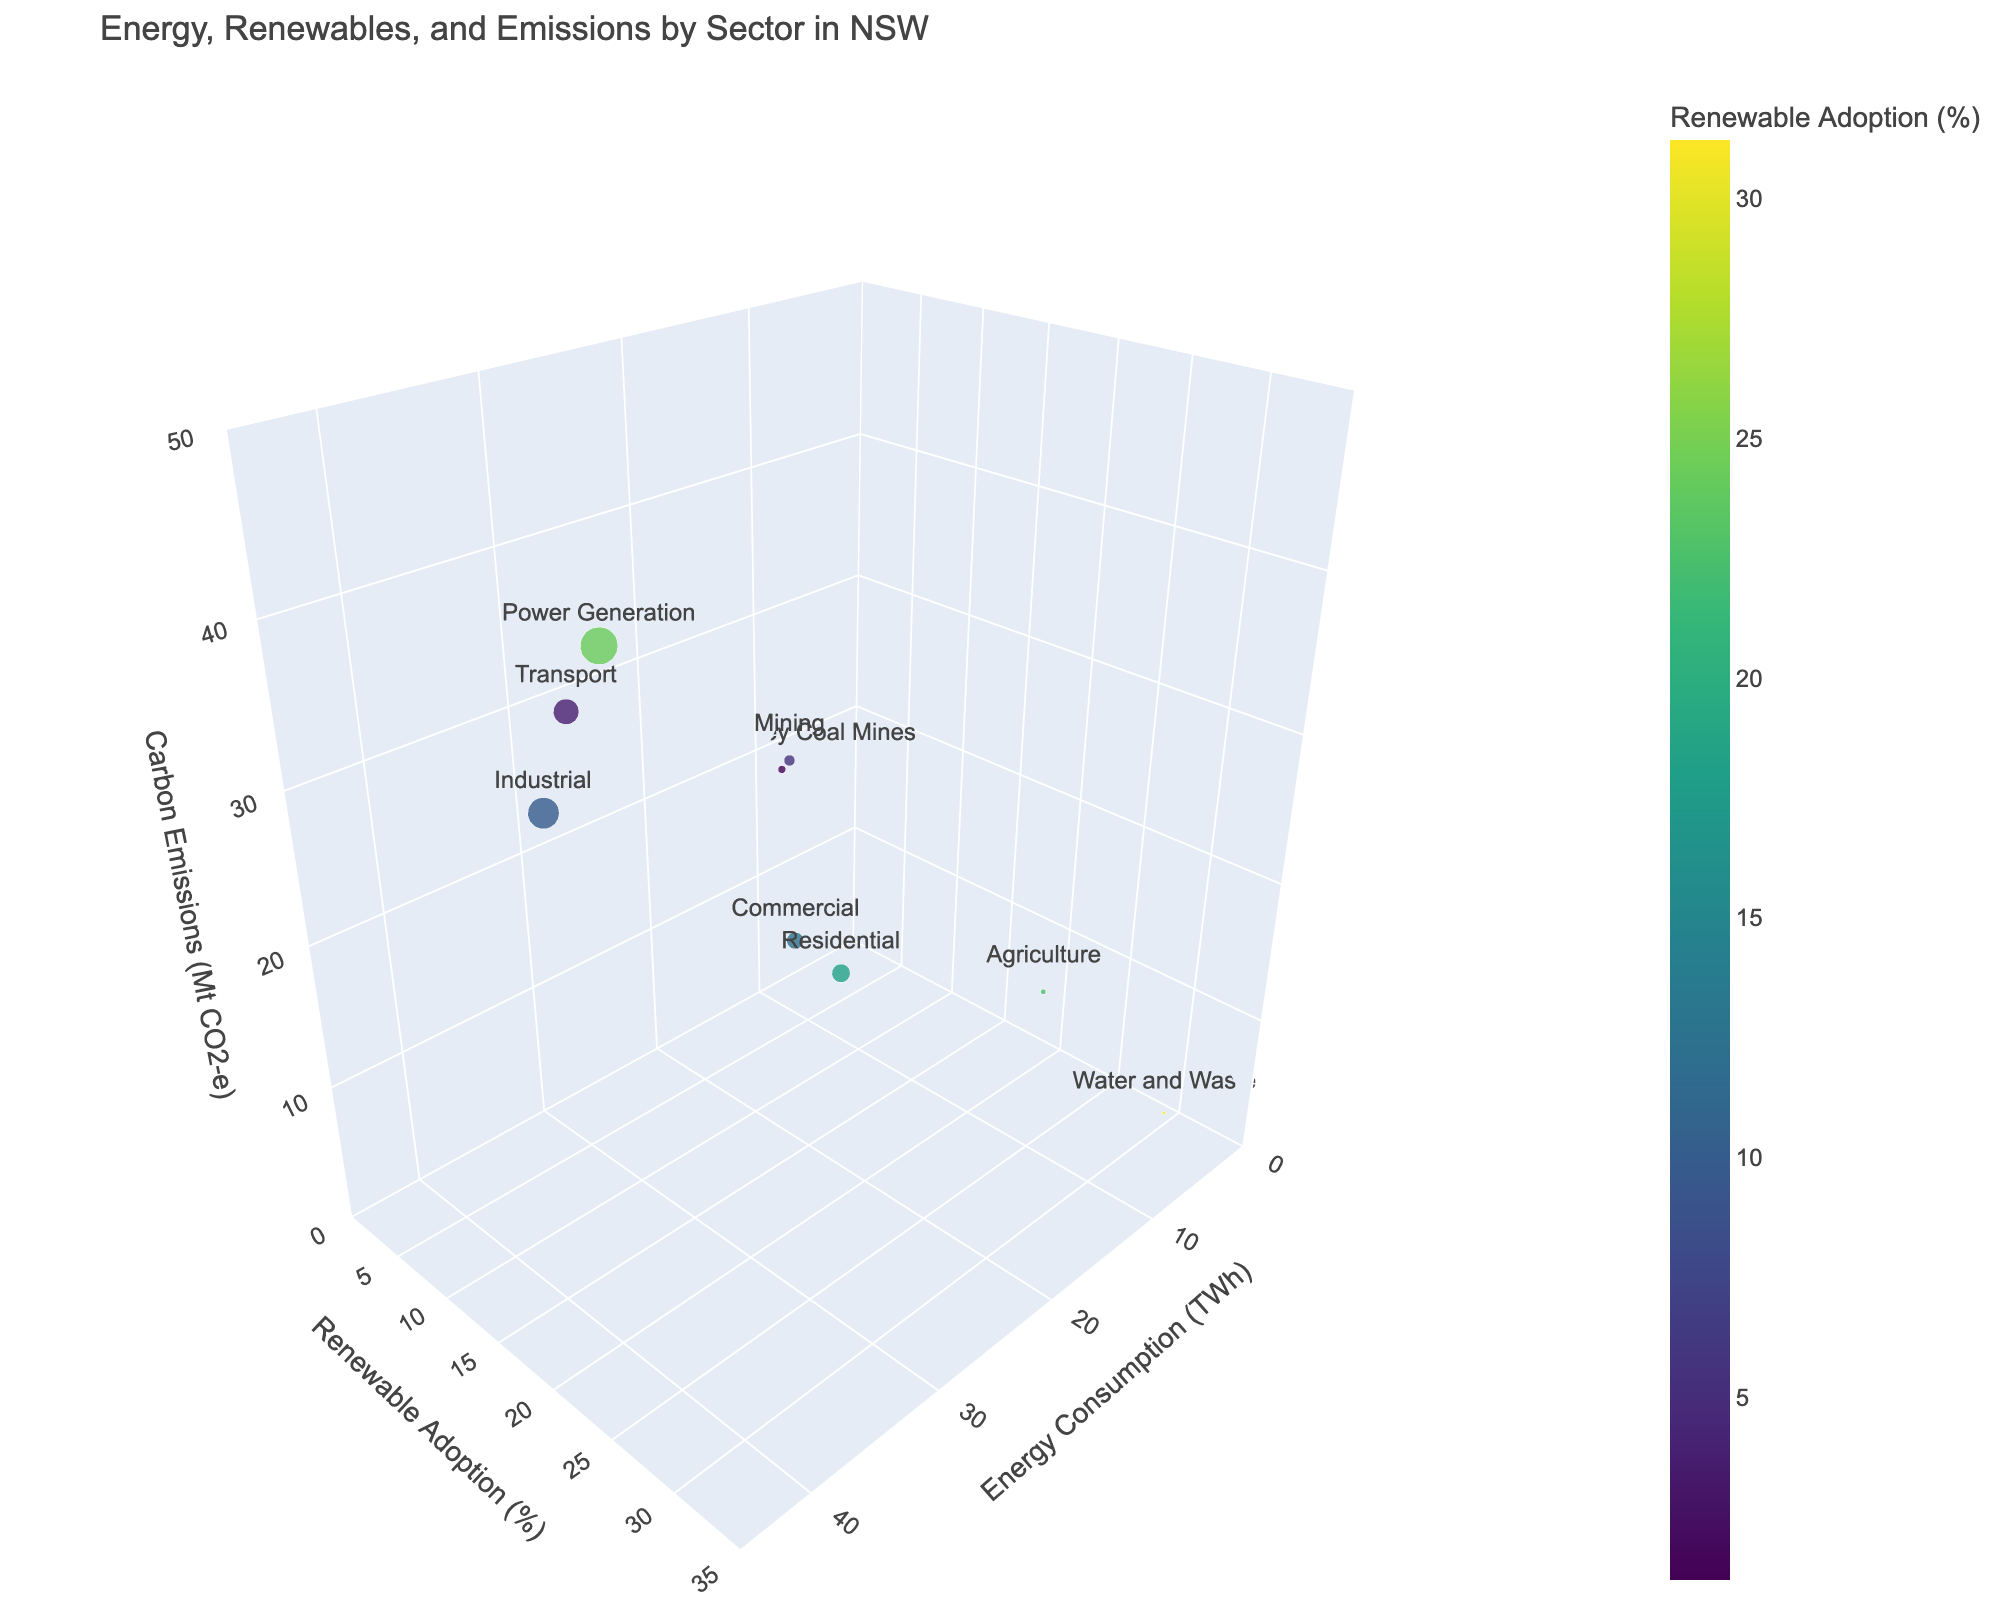What's the title of the figure? The title is located at the top of the figure, clearly stating the topic of the chart.
Answer: Energy, Renewables, and Emissions by Sector in NSW How many sectors are represented in the figure? Each unique marker corresponds to a sector, with the sector names provided in the 'text' attribute of the markers. Count these unique markers.
Answer: 9 Which sector has the highest carbon emissions? Look at the 'z' axis for the sector with the highest value.
Answer: Power Generation What is the renewable adoption percentage for the mining sector? Find the mining sector bubble and check the 'y' axis position to determine the renewable adoption percentage.
Answer: 5.6% Which sector has the lowest renewable adoption rate? Identify the smallest value on the 'y' axis by examining each sector's position on this axis.
Answer: Hunter Valley Coal Mines Compare the energy consumption of the transport and commercial sectors and identify which one is higher. Check the 'x' axis coordinates of both sectors and compare the values.
Answer: Transport What is the average renewable adoption percentage across all sectors? Sum the renewable adoption percentages of all sectors and divide by the number of sectors: (18.2 + 12.5 + 9.8 + 5.6 + 22.4 + 3.7 + 24.3 + 31.2 + 1.2) / 9.
Answer: 14.32% Which sector has the smallest bubble size, and what does it represent? The bubble size is proportional to the energy consumption. Identify the sector with the smallest bubble.
Answer: Water and Waste; 3.9 TWh How does the carbon emissions of the industrial sector compare to the residential sector? Locate both sectors on the 'z' axis and compare their carbon emissions values.
Answer: Industrial sector emits more CO2 (28.7 Mt vs. 15.3 Mt) What can be inferred about sectors with high energy consumption in terms of renewable adoption percentages? Analyze the trends in the figure by examining the data points with high 'x' axis values and their corresponding 'y' axis values.
Answer: Generally, high energy consumption sectors have lower renewable adoption percentages 